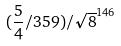Convert formula to latex. <formula><loc_0><loc_0><loc_500><loc_500>( \frac { 5 } { 4 } / 3 5 9 ) / \sqrt { 8 } ^ { 1 4 6 }</formula> 